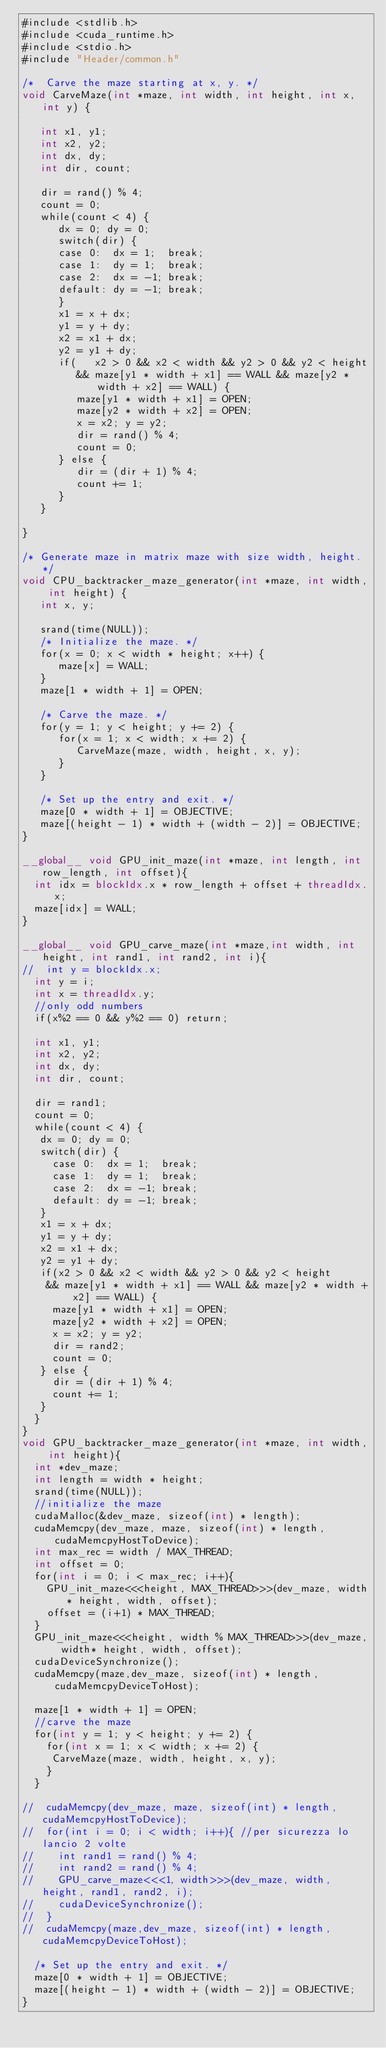Convert code to text. <code><loc_0><loc_0><loc_500><loc_500><_Cuda_>#include <stdlib.h>
#include <cuda_runtime.h>
#include <stdio.h>
#include "Header/common.h"

/*  Carve the maze starting at x, y. */
void CarveMaze(int *maze, int width, int height, int x, int y) {

   int x1, y1;
   int x2, y2;
   int dx, dy;
   int dir, count;

   dir = rand() % 4;
   count = 0;
   while(count < 4) {
      dx = 0; dy = 0;
      switch(dir) {
      case 0:  dx = 1;  break;
      case 1:  dy = 1;  break;
      case 2:  dx = -1; break;
      default: dy = -1; break;
      }
      x1 = x + dx;
      y1 = y + dy;
      x2 = x1 + dx;
      y2 = y1 + dy;
      if(   x2 > 0 && x2 < width && y2 > 0 && y2 < height
         && maze[y1 * width + x1] == WALL && maze[y2 * width + x2] == WALL) {
         maze[y1 * width + x1] = OPEN;
         maze[y2 * width + x2] = OPEN;
         x = x2; y = y2;
         dir = rand() % 4;
         count = 0;
      } else {
         dir = (dir + 1) % 4;
         count += 1;
      }
   }

}

/* Generate maze in matrix maze with size width, height. */
void CPU_backtracker_maze_generator(int *maze, int width, int height) {
   int x, y;

   srand(time(NULL));
   /* Initialize the maze. */
   for(x = 0; x < width * height; x++) {
      maze[x] = WALL;
   }
   maze[1 * width + 1] = OPEN;

   /* Carve the maze. */
   for(y = 1; y < height; y += 2) {
      for(x = 1; x < width; x += 2) {
         CarveMaze(maze, width, height, x, y);
      }
   }

   /* Set up the entry and exit. */
   maze[0 * width + 1] = OBJECTIVE;
   maze[(height - 1) * width + (width - 2)] = OBJECTIVE;
}

__global__ void GPU_init_maze(int *maze, int length, int row_length, int offset){
	int idx = blockIdx.x * row_length + offset + threadIdx.x;
	maze[idx] = WALL;
}

__global__ void GPU_carve_maze(int *maze,int width, int height, int rand1, int rand2, int i){
//	int y = blockIdx.x;
	int y = i;
	int x = threadIdx.y;
	//only odd numbers
	if(x%2 == 0 && y%2 == 0) return;

	int x1, y1;
	int x2, y2;
	int dx, dy;
	int dir, count;

	dir = rand1;
	count = 0;
	while(count < 4) {
	 dx = 0; dy = 0;
	 switch(dir) {
		 case 0:  dx = 1;  break;
		 case 1:  dy = 1;  break;
		 case 2:  dx = -1; break;
		 default: dy = -1; break;
	 }
	 x1 = x + dx;
	 y1 = y + dy;
	 x2 = x1 + dx;
	 y2 = y1 + dy;
	 if(x2 > 0 && x2 < width && y2 > 0 && y2 < height
		&& maze[y1 * width + x1] == WALL && maze[y2 * width + x2] == WALL) {
		 maze[y1 * width + x1] = OPEN;
		 maze[y2 * width + x2] = OPEN;
		 x = x2; y = y2;
		 dir = rand2;
		 count = 0;
	 } else {
		 dir = (dir + 1) % 4;
		 count += 1;
	 }
	}
}
void GPU_backtracker_maze_generator(int *maze, int width, int height){
	int *dev_maze;
	int length = width * height;
	srand(time(NULL));
	//initialize the maze
	cudaMalloc(&dev_maze, sizeof(int) * length);
	cudaMemcpy(dev_maze, maze, sizeof(int) * length, cudaMemcpyHostToDevice);
	int max_rec = width / MAX_THREAD;
	int offset = 0;
	for(int i = 0; i < max_rec; i++){
		GPU_init_maze<<<height, MAX_THREAD>>>(dev_maze, width* height, width, offset);
		offset = (i+1) * MAX_THREAD;
	}
	GPU_init_maze<<<height, width % MAX_THREAD>>>(dev_maze, width* height, width, offset);
	cudaDeviceSynchronize();
	cudaMemcpy(maze,dev_maze, sizeof(int) * length, cudaMemcpyDeviceToHost);

	maze[1 * width + 1] = OPEN;
	//carve the maze
	for(int y = 1; y < height; y += 2) {
	  for(int x = 1; x < width; x += 2) {
		 CarveMaze(maze, width, height, x, y);
	  }
	}

//	cudaMemcpy(dev_maze, maze, sizeof(int) * length, cudaMemcpyHostToDevice);
//	for(int i = 0; i < width; i++){	//per sicurezza lo lancio 2 volte
//		int rand1 = rand() % 4;
//		int rand2 = rand() % 4;
//		GPU_carve_maze<<<1, width>>>(dev_maze, width, height, rand1, rand2, i);
//		cudaDeviceSynchronize();
//	}
//	cudaMemcpy(maze,dev_maze, sizeof(int) * length, cudaMemcpyDeviceToHost);

	/* Set up the entry and exit. */
	maze[0 * width + 1] = OBJECTIVE;
	maze[(height - 1) * width + (width - 2)] = OBJECTIVE;
}
</code> 